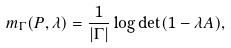Convert formula to latex. <formula><loc_0><loc_0><loc_500><loc_500>m _ { \Gamma } ( P , \lambda ) = \frac { 1 } { | \Gamma | } \log \det ( 1 - \lambda A ) ,</formula> 